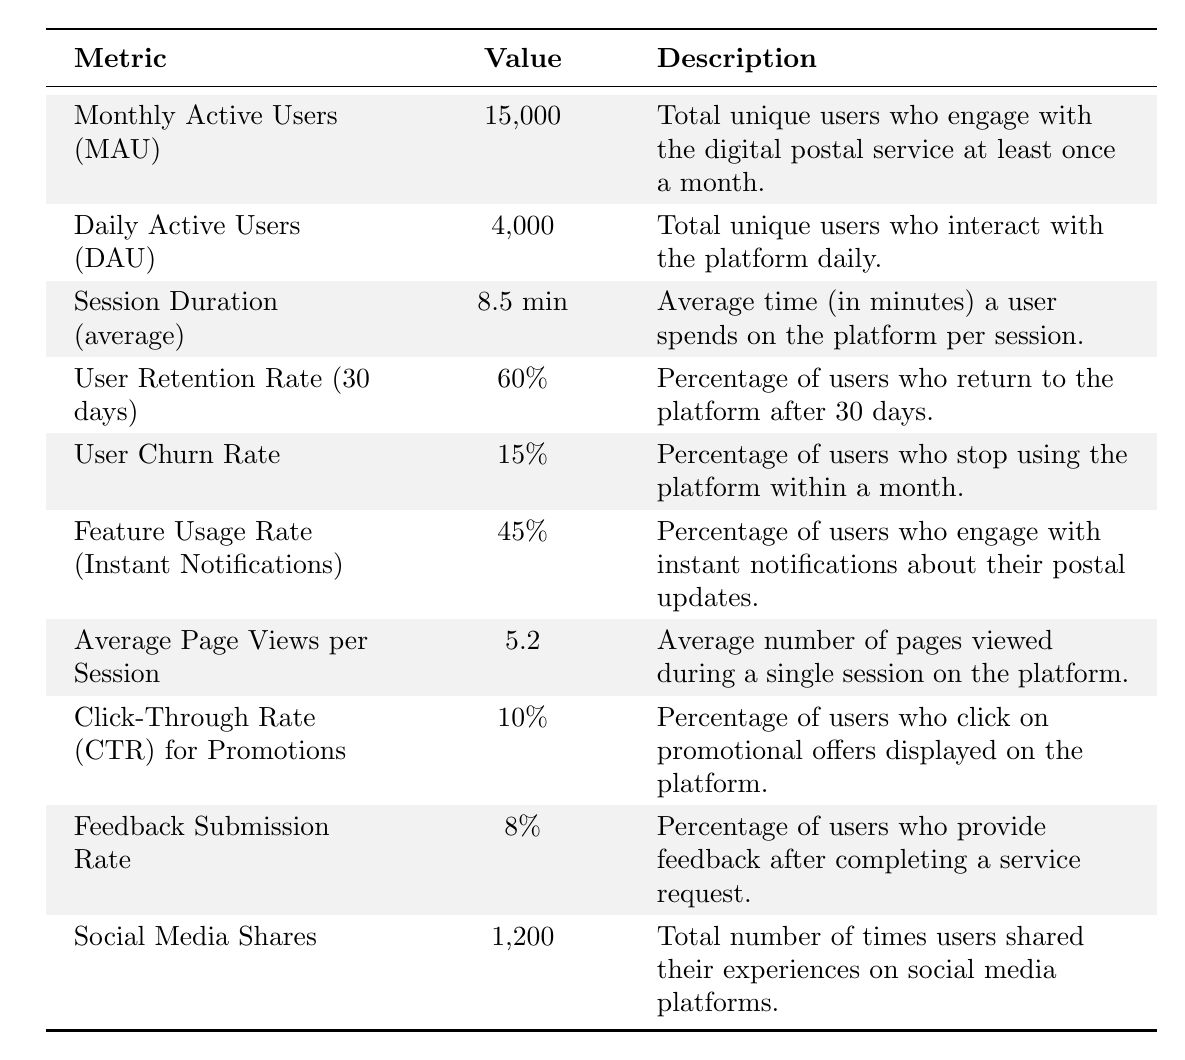What is the Monthly Active Users (MAU)? The table directly states that the Monthly Active Users (MAU) is 15,000.
Answer: 15,000 How many Daily Active Users (DAU) are there? The table indicates that the Daily Active Users (DAU) is 4,000.
Answer: 4,000 What is the average Session Duration? According to the table, the average Session Duration is 8.5 minutes.
Answer: 8.5 min What is the User Retention Rate after 30 days? The User Retention Rate (30 days) is explicitly given in the table as 60%.
Answer: 60% What is the User Churn Rate? The table shows that the User Churn Rate is 15%.
Answer: 15% What percentage of users engage with Instant Notifications? The table states that the Feature Usage Rate (Instant Notifications) is 45%.
Answer: 45% What are the Average Page Views per Session? According to the table, the Average Page Views per Session is 5.2.
Answer: 5.2 What is the Click-Through Rate for Promotions? The table lists the Click-Through Rate (CTR) for Promotions as 10%.
Answer: 10% How many users provide feedback after completing a service request? The Feedback Submission Rate in the table indicates that 8% of users provide feedback.
Answer: 8% What is the total number of Social Media Shares? The Social Media Shares total according to the table is 1,200.
Answer: 1,200 What is the ratio of Daily Active Users (DAU) to Monthly Active Users (MAU)? To find the ratio, divide DAU by MAU: 4,000 / 15,000 = 0.267, or approximately 26.7%.
Answer: 26.7% If the User Retention Rate is 60%, what is the User Churn Rate? Since the User Retention Rate is 60%, the User Churn Rate can be calculated as 100% - 60% = 40%. This is not consistent with the stated churn rate of 15%, indicating a discrepancy.
Answer: Discrepancy How many users are retained after 30 days if the Monthly Active Users are 15,000 and the User Retention Rate is 60%? To find the retained users, calculate 60% of 15,000, which is 15,000 * 0.60 = 9,000 users retained.
Answer: 9,000 What is the total interaction time for Daily Active Users over a month given the average Session Duration? To find the total interaction time, calculate the total sessions in a month: DAU (4,000) * average Session Duration (8.5 min) * number of days in a month (30): 4,000 * 8.5 * 30 = 1,020,000 minutes.
Answer: 1,020,000 minutes What percentage of users engage with both instant notifications and provide feedback if these rates are independent? Assuming independence, multiply the engagement rates: 45% (instant notifications) * 8% (feedback) = 0.45 * 0.08 = 0.036 or 3.6%.
Answer: 3.6% 